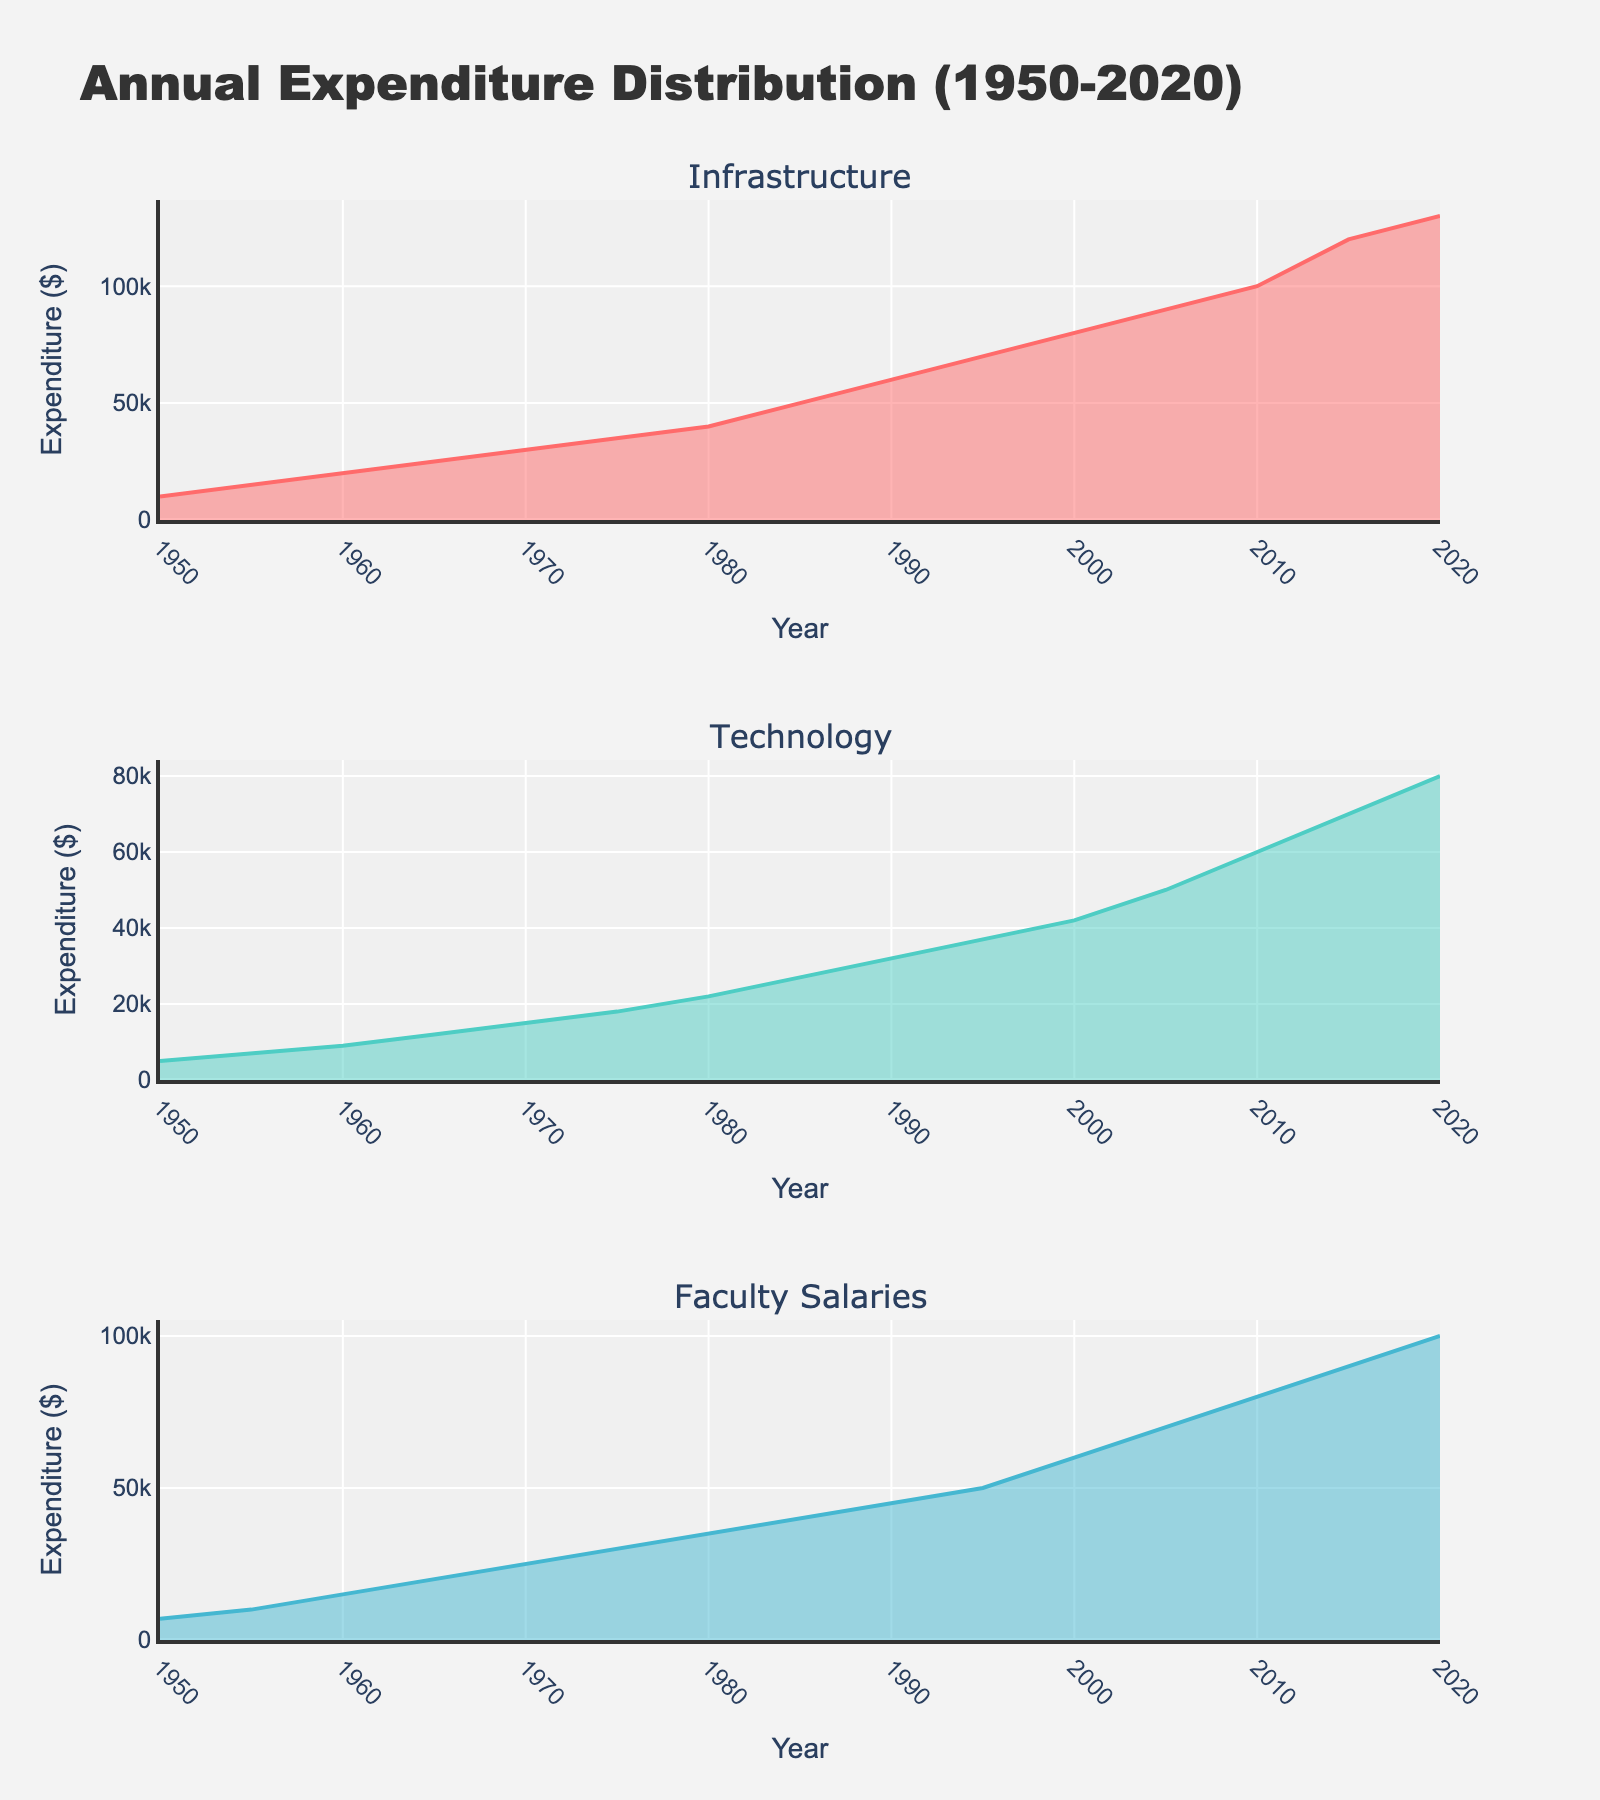What's the title of the figure? Look at the top of the figure where the title is usually displayed. It states the overall theme or main subject represented by the plot.
Answer: Annual Expenditure Distribution (1950-2020) What is the average expenditure on Technology over the entire period? To calculate the average, sum up all the values for Technology and divide by the number of data points. (5000+7000+9000+12000+15000+18000+22000+27000+32000+37000+42000+50000+60000+70000+80000)/15 = 31,000
Answer: 31,000 Which category had the highest expenditure in 2020? Check the data for the year 2020 in each subplot, compare the values for Infrastructure, Technology, and Faculty Salaries. Faculty Salaries had 100,000, which is higher than the others.
Answer: Faculty Salaries By how much did the Infrastructure expenditure increase from 1950 to 1980? Locate the Infra-structure values for 1950 and 1980, which are 10,000 and 40,000, respectively. Subtract the former from the latter to find the increase. 40,000 - 10,000 = 30,000
Answer: 30,000 Which subplot shows the most significant increase in expenditure over the years? Compare the shape and slope of the area charts across the subplots. Faculty Salaries had the most significant increase, rising from 7,000 in 1950 to 100,000 in 2020.
Answer: Faculty Salaries What is the trend in Technology expenditure from 2000 to 2020? Look at the Technology subplot and observe the pattern from 2000 to 2020. The expenditure increases steadily from 42,000 in 2000 to 80,000 in 2020.
Answer: Increasing trend How did the annual expenditure distribution change from 1950 to 1990 for Infrastructure vs Technology? Compare the values in the respective years: For Infrastructure, it increases from 10,000 to 60,000. For Technology, it increases from 5,000 to 32,000. Both increased, but Infrastructure increased more significantly.
Answer: Infrastructure increased more What was the difference in faculty salaries expenditure between 1970 and 2010? Find the values for Faculty Salaries in 1970 and 2010, which are 25,000 and 80,000, respectively. Subtract 25,000 from 80,000 to get the difference.
Answer: 55,000 Which year had a significant jump in Technology expenditure compared to the previous years? Look for the year where the increase in expenditure is noticeably larger than previous increments. The biggest jump appears between 2000 and 2005, going from 42,000 to 50,000.
Answer: 2005 